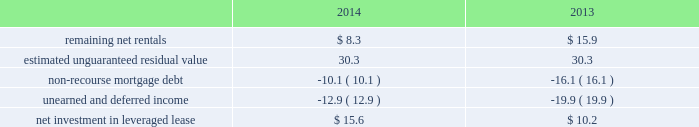Kimco realty corporation and subsidiaries notes to consolidated financial statements , continued during 2012 , the albertsons joint venture distributed $ 50.3 million of which the company received $ 6.9 million , which was recognized as income from cash received in excess of the company 2019s investment , before income tax , and is included in equity in income from other real estate investments , net on the company 2019s consolidated statements of income .
In january 2015 , the company invested an additional $ 85.3 million of new equity in the company 2019s albertsons joint venture to facilitate the acquisition of safeway inc .
By the cerberus lead consortium .
As a result , kimco now holds a 9.8% ( 9.8 % ) ownership interest in the combined company which operates 2230 stores across 34 states .
Leveraged lease - during june 2002 , the company acquired a 90% ( 90 % ) equity participation interest in an existing leveraged lease of 30 properties .
The properties are leased under a long-term bond-type net lease whose primary term expires in 2016 , with the lessee having certain renewal option rights .
The company 2019s cash equity investment was $ 4.0 million .
This equity investment is reported as a net investment in leveraged lease in accordance with the fasb 2019s lease guidance .
As of december 31 , 2014 , 19 of these properties were sold , whereby the proceeds from the sales were used to pay down $ 32.3 million in mortgage debt and the remaining 11 properties remain encumbered by third-party non-recourse debt of $ 11.2 million that is scheduled to fully amortize during the primary term of the lease from a portion of the periodic net rents receivable under the net lease .
As an equity participant in the leveraged lease , the company has no recourse obligation for principal or interest payments on the debt , which is collateralized by a first mortgage lien on the properties and collateral assignment of the lease .
Accordingly , this obligation has been offset against the related net rental receivable under the lease .
At december 31 , 2014 and 2013 , the company 2019s net investment in the leveraged lease consisted of the following ( in millions ) : .
Variable interest entities : consolidated ground-up development projects included within the company 2019s ground-up development projects at december 31 , 2014 , is an entity that is a vie , for which the company is the primary beneficiary .
This entity was established to develop real estate property to hold as a long-term investment .
The company 2019s involvement with this entity is through its majority ownership and management of the property .
This entity was deemed a vie primarily based on the fact that the equity investment at risk is not sufficient to permit the entity to finance its activities without additional financial support .
The initial equity contributed to this entity was not sufficient to fully finance the real estate construction as development costs are funded by the partners throughout the construction period .
The company determined that it was the primary beneficiary of this vie as a result of its controlling financial interest .
At december 31 , 2014 , total assets of this ground-up development vie were $ 77.7 million and total liabilities were $ 0.1 million .
The classification of these assets is primarily within real estate under development in the company 2019s consolidated balance sheets and the classifications of liabilities are primarily within accounts payable and accrued expenses on the company 2019s consolidated balance sheets .
Substantially all of the projected development costs to be funded for this ground-up development vie , aggregating $ 32.8 million , will be funded with capital contributions from the company and by the outside partners , when contractually obligated .
The company has not provided financial support to this vie that it was not previously contractually required to provide. .
What is the average net rentals for 2013-2014 , in millions? 
Computations: ((8.3 + 15.9) / 2)
Answer: 12.1. 